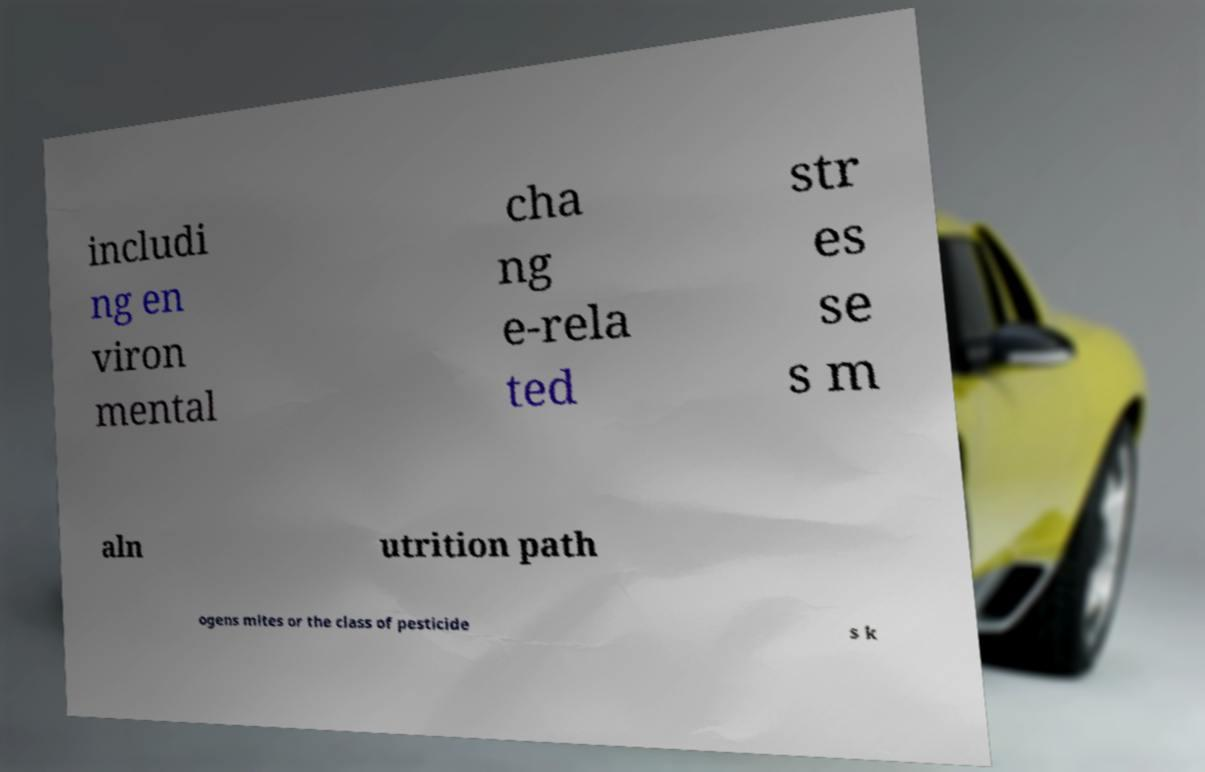Can you accurately transcribe the text from the provided image for me? includi ng en viron mental cha ng e-rela ted str es se s m aln utrition path ogens mites or the class of pesticide s k 